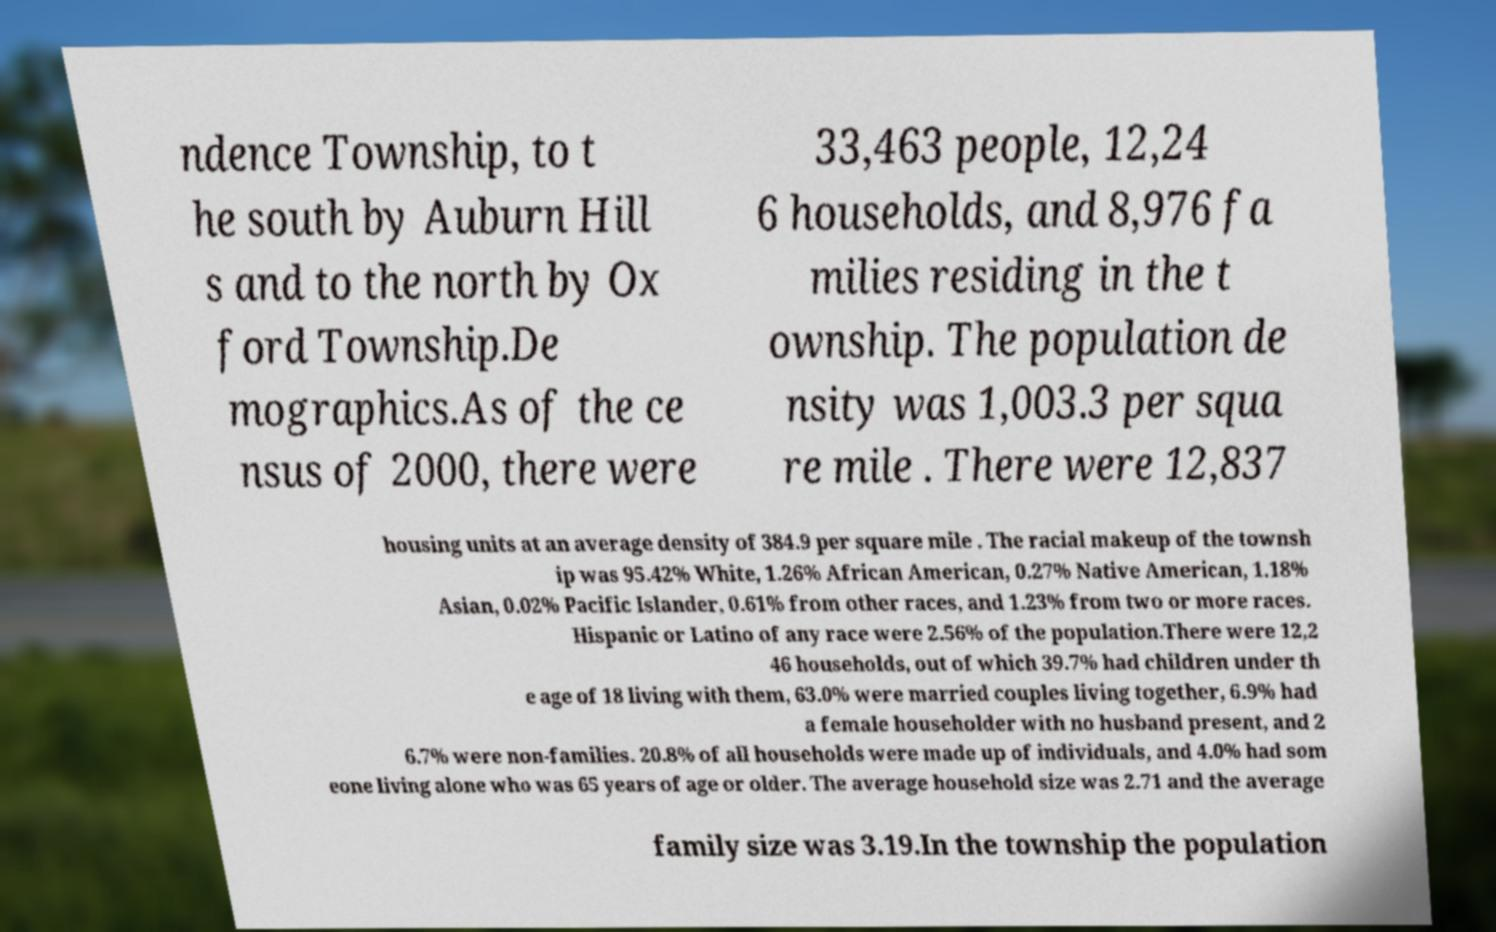Could you assist in decoding the text presented in this image and type it out clearly? ndence Township, to t he south by Auburn Hill s and to the north by Ox ford Township.De mographics.As of the ce nsus of 2000, there were 33,463 people, 12,24 6 households, and 8,976 fa milies residing in the t ownship. The population de nsity was 1,003.3 per squa re mile . There were 12,837 housing units at an average density of 384.9 per square mile . The racial makeup of the townsh ip was 95.42% White, 1.26% African American, 0.27% Native American, 1.18% Asian, 0.02% Pacific Islander, 0.61% from other races, and 1.23% from two or more races. Hispanic or Latino of any race were 2.56% of the population.There were 12,2 46 households, out of which 39.7% had children under th e age of 18 living with them, 63.0% were married couples living together, 6.9% had a female householder with no husband present, and 2 6.7% were non-families. 20.8% of all households were made up of individuals, and 4.0% had som eone living alone who was 65 years of age or older. The average household size was 2.71 and the average family size was 3.19.In the township the population 